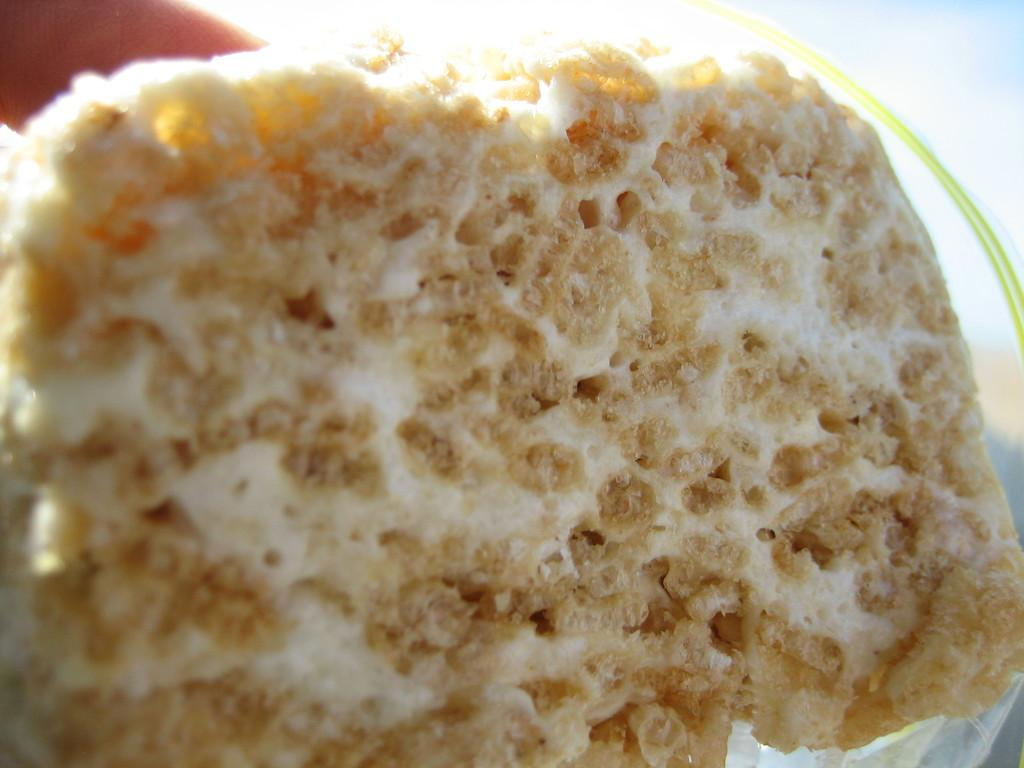What is the main subject of the image? There is a food item in the image. Can you describe the background of the image? The background of the image is blurred. What town is the parent visiting in the image? There is no parent or town present in the image; it only features a food item and a blurred background. 